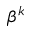<formula> <loc_0><loc_0><loc_500><loc_500>\beta ^ { k }</formula> 